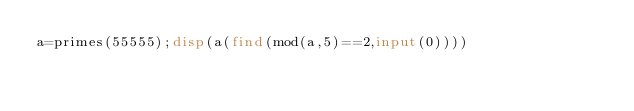Convert code to text. <code><loc_0><loc_0><loc_500><loc_500><_Octave_>a=primes(55555);disp(a(find(mod(a,5)==2,input(0))))</code> 